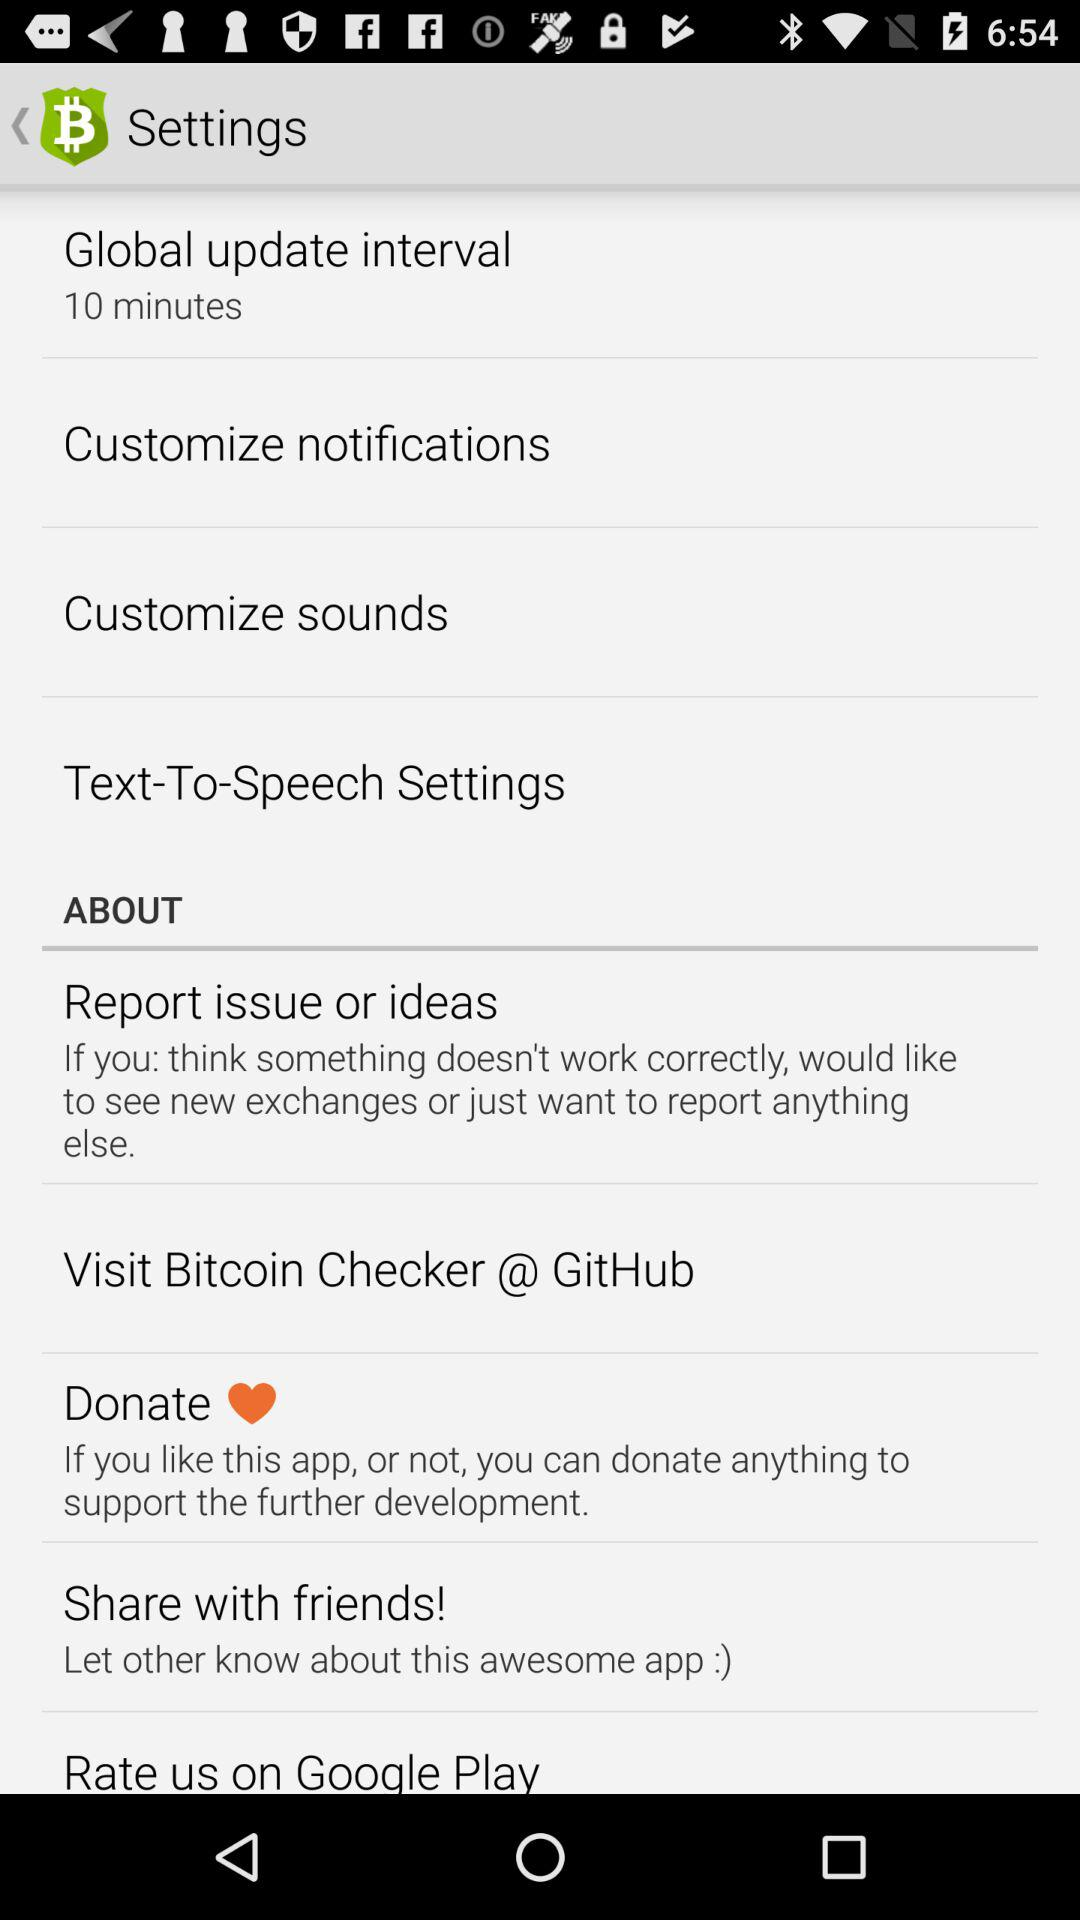What is the duration of the global update interval? The duration of the global update interval is 10 minutes. 